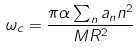Convert formula to latex. <formula><loc_0><loc_0><loc_500><loc_500>\omega _ { c } = \frac { \pi \alpha \sum _ { n } a _ { n } n ^ { 2 } } { M R ^ { 2 } }</formula> 